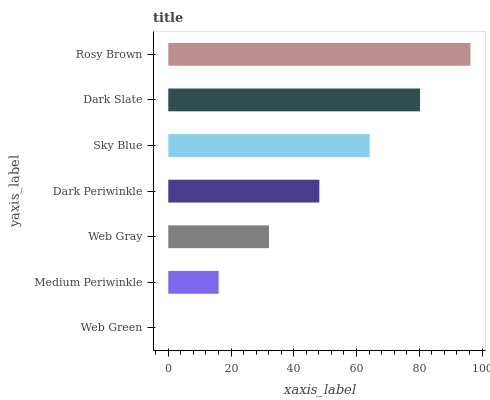Is Web Green the minimum?
Answer yes or no. Yes. Is Rosy Brown the maximum?
Answer yes or no. Yes. Is Medium Periwinkle the minimum?
Answer yes or no. No. Is Medium Periwinkle the maximum?
Answer yes or no. No. Is Medium Periwinkle greater than Web Green?
Answer yes or no. Yes. Is Web Green less than Medium Periwinkle?
Answer yes or no. Yes. Is Web Green greater than Medium Periwinkle?
Answer yes or no. No. Is Medium Periwinkle less than Web Green?
Answer yes or no. No. Is Dark Periwinkle the high median?
Answer yes or no. Yes. Is Dark Periwinkle the low median?
Answer yes or no. Yes. Is Web Green the high median?
Answer yes or no. No. Is Medium Periwinkle the low median?
Answer yes or no. No. 